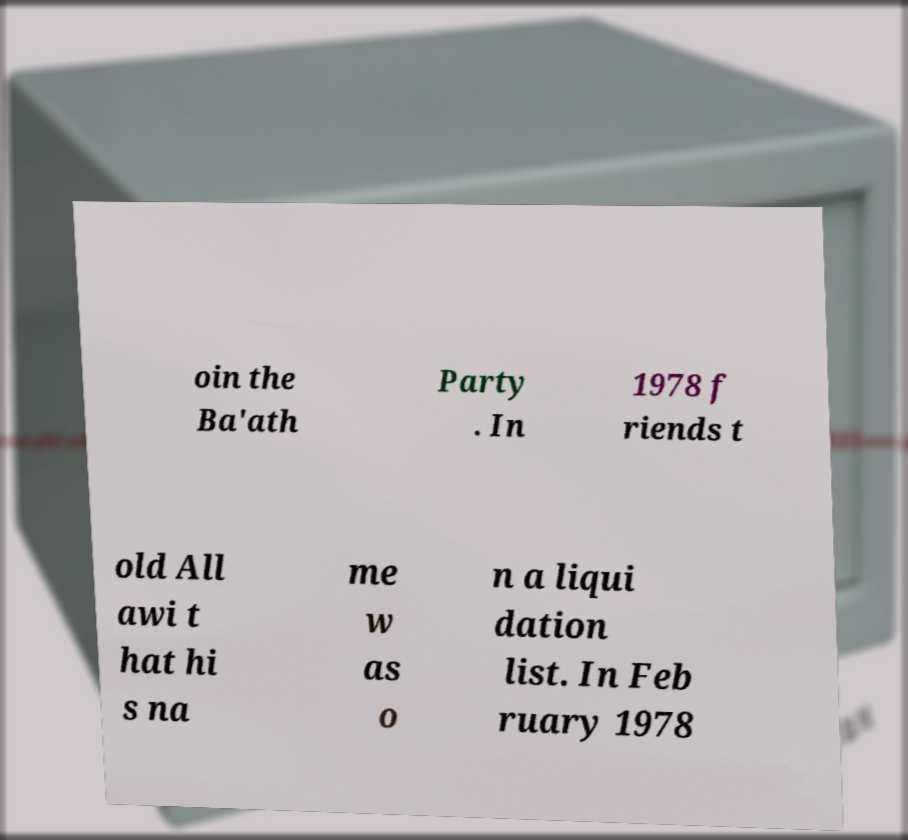Please identify and transcribe the text found in this image. oin the Ba'ath Party . In 1978 f riends t old All awi t hat hi s na me w as o n a liqui dation list. In Feb ruary 1978 